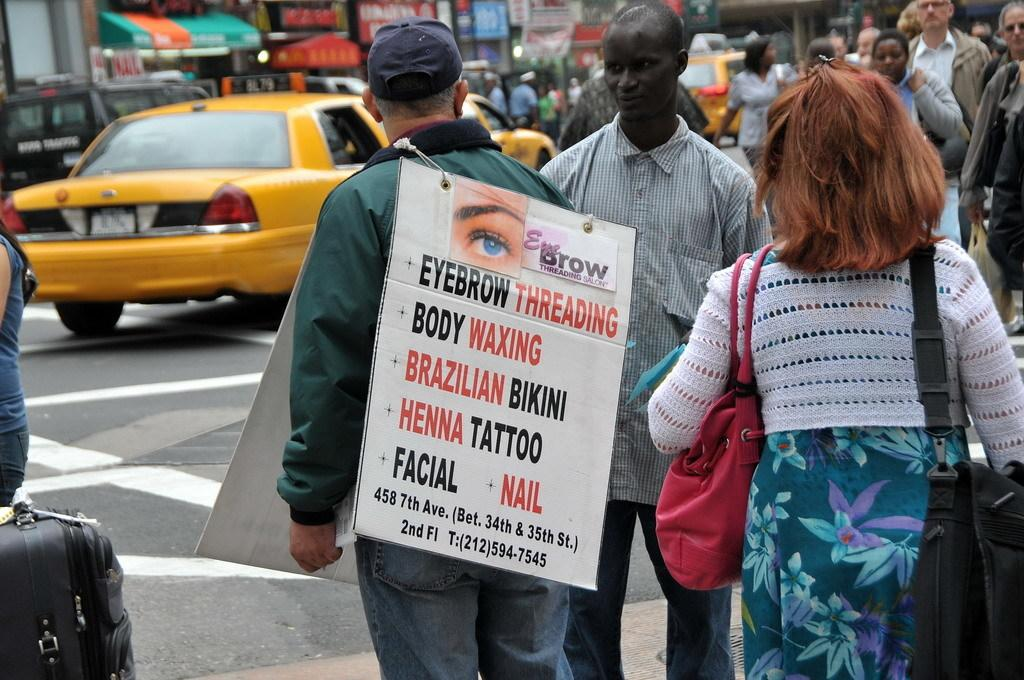What is happening in the image involving the group of people? The people are walking in the image. Can you describe the person leading the group? There is a person in front holding two boards. What can be seen in the background of the image? There are vehicles and stalls in the background of the image. How many children are present in the image? There is no specific mention of children in the image, so it cannot be determined from the provided facts. 